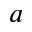<formula> <loc_0><loc_0><loc_500><loc_500>a</formula> 